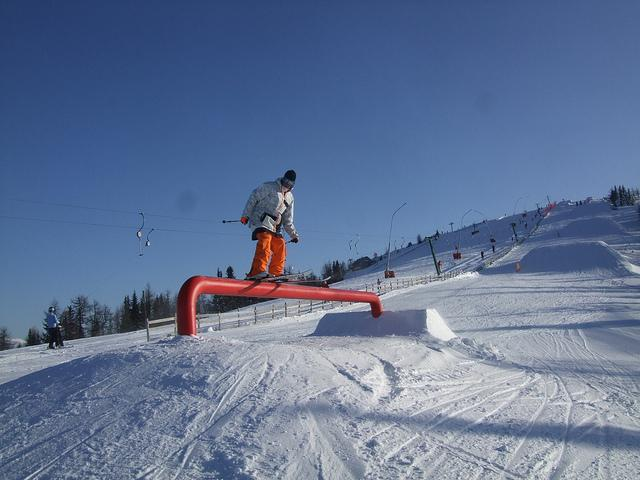What is the man going to do next?

Choices:
A) jumping off
B) flipping over
C) lying down
D) sitting down jumping off 